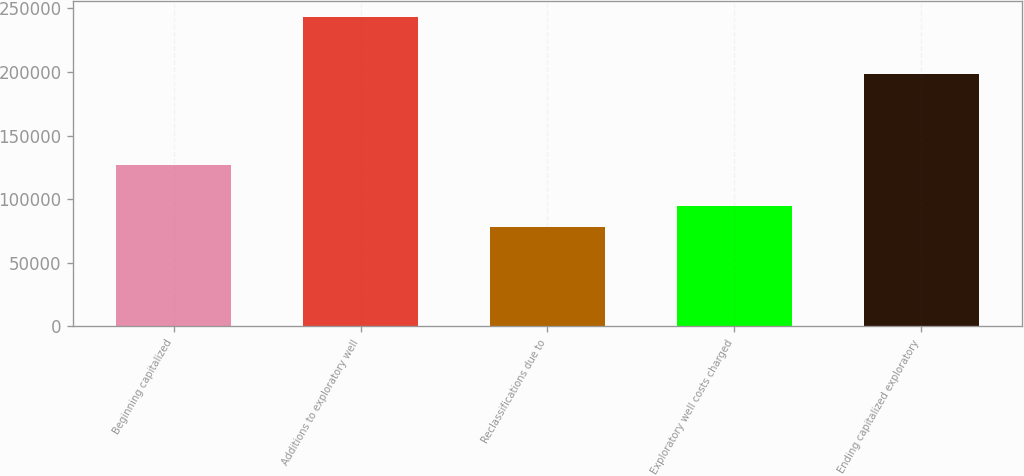<chart> <loc_0><loc_0><loc_500><loc_500><bar_chart><fcel>Beginning capitalized<fcel>Additions to exploratory well<fcel>Reclassifications due to<fcel>Exploratory well costs charged<fcel>Ending capitalized exploratory<nl><fcel>126472<fcel>243272<fcel>78334<fcel>94827.8<fcel>198291<nl></chart> 